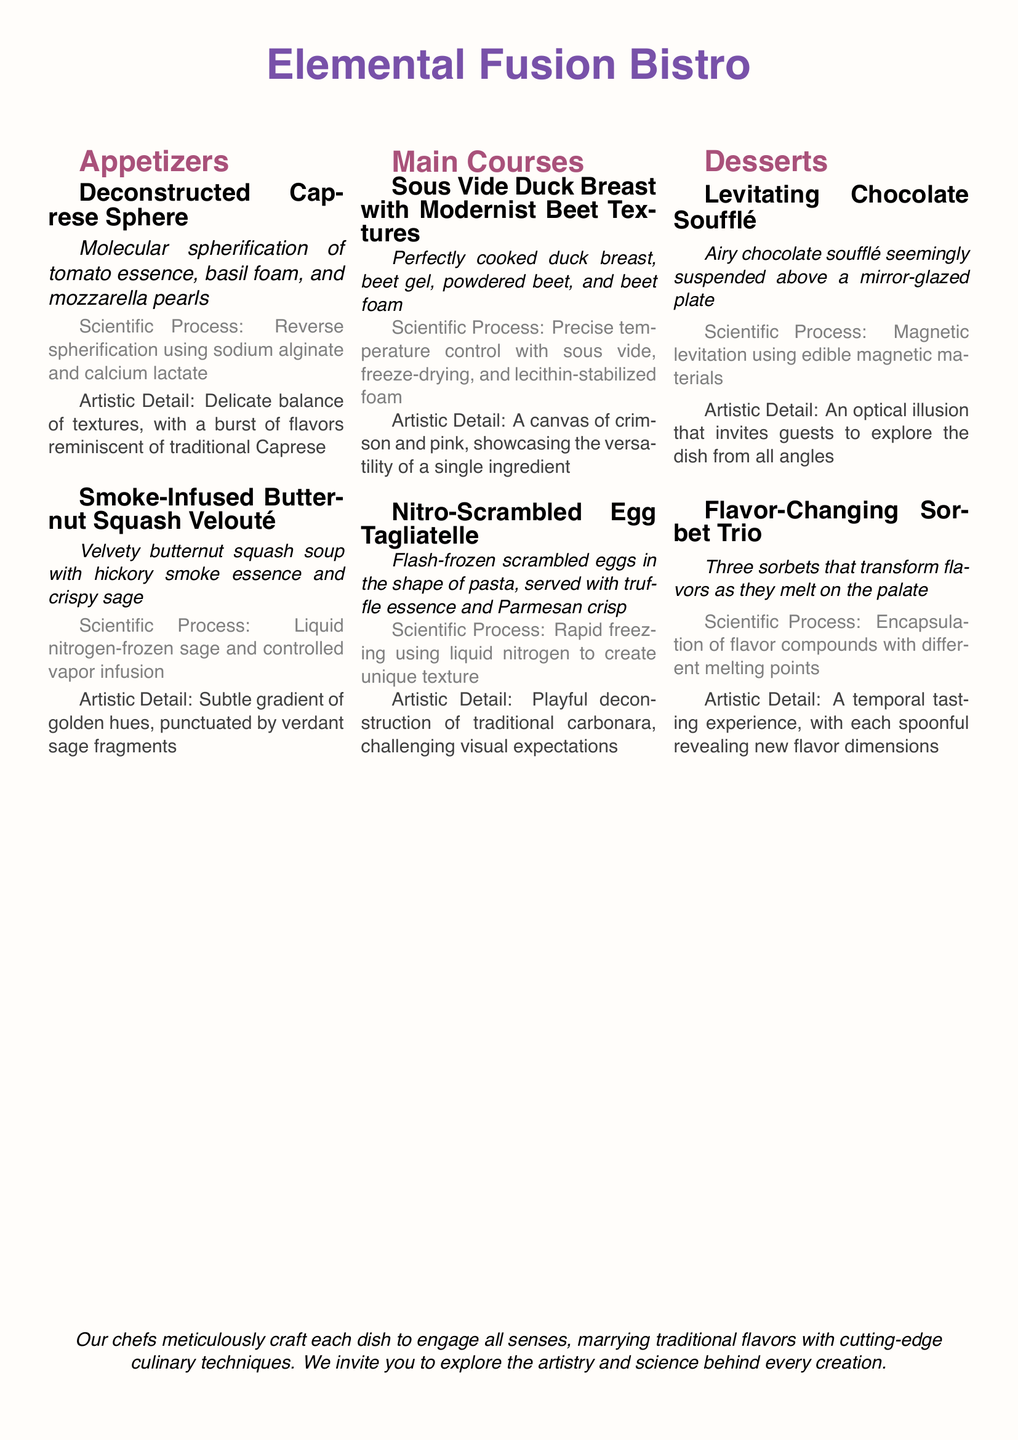What is the name of the bistro? The name of the bistro is prominently displayed at the top of the document as "Elemental Fusion Bistro."
Answer: Elemental Fusion Bistro What is the scientific process used in the Deconstructed Caprese Sphere? The document states that the scientific process involves reverse spherification using sodium alginate and calcium lactate.
Answer: Reverse spherification using sodium alginate and calcium lactate How many appetizers are listed on the menu? The document lists a total of two appetizers under the appetizers section.
Answer: 2 What technique is used to create the Nitro-Scrambled Egg Tagliatelle? The document explains that rapid freezing using liquid nitrogen is the technique used for this dish.
Answer: Liquid nitrogen What flavors are included in the Flavor-Changing Sorbet Trio? The document specifies that the trio includes three different sorbets that transform flavors.
Answer: Three sorbets What is the main ingredient in the Sous Vide Duck Breast with Modernist Beet Textures? The main ingredient highlighted in this dish is duck breast.
Answer: Duck breast What artistic detail is noted for the Levitating Chocolate Soufflé? The document mentions that it creates an optical illusion that invites guests to explore the dish from all angles.
Answer: An optical illusion What cooking method is utilized for the Smoke-Infused Butternut Squash Velouté? The document states that liquid nitrogen-frozen sage and controlled vapor infusion are used in this dish.
Answer: Vapor infusion 